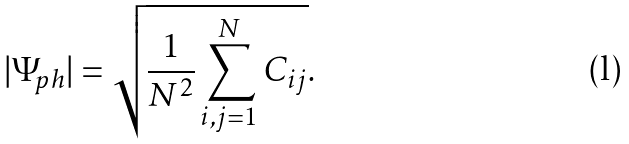Convert formula to latex. <formula><loc_0><loc_0><loc_500><loc_500>| \Psi _ { p h } | = \sqrt { \frac { 1 } { N ^ { 2 } } \sum _ { i , j = 1 } ^ { N } C _ { i j } } .</formula> 